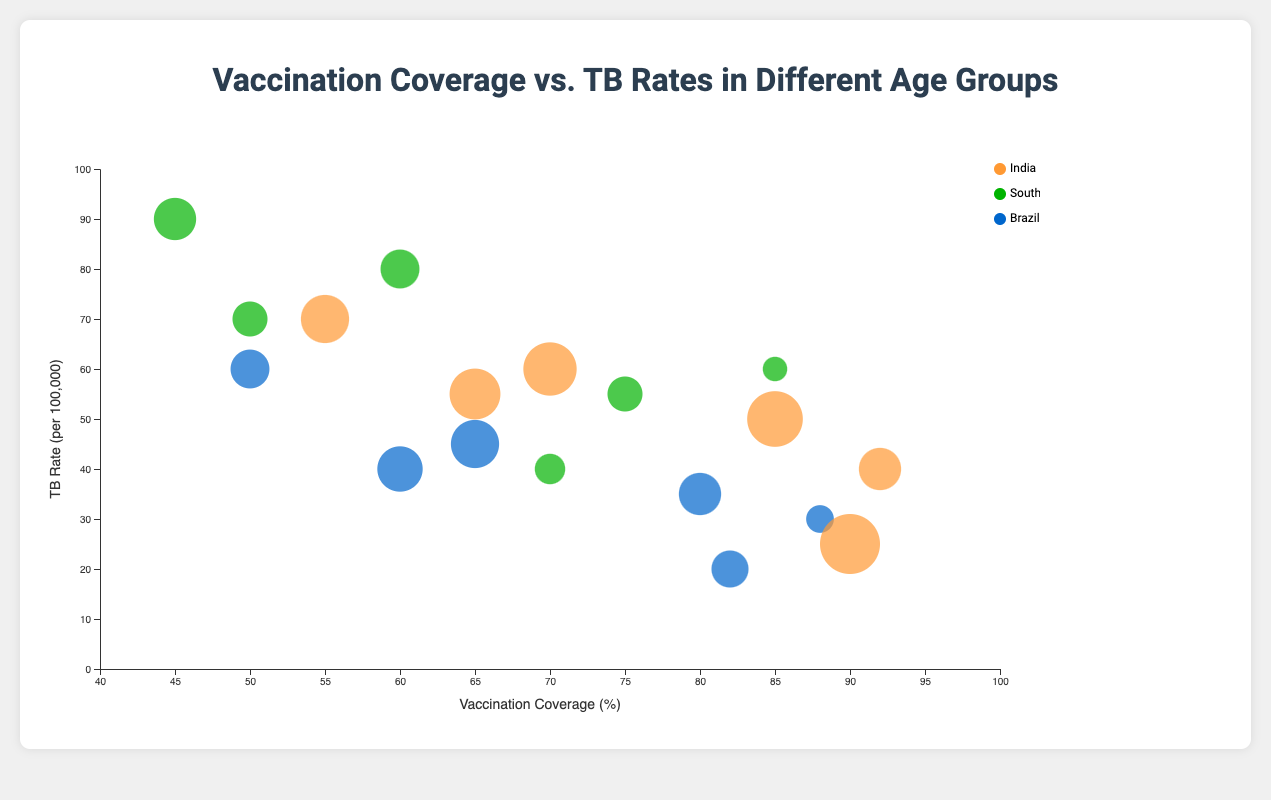What is the title of the figure? The title is located at the top center of the figure, typically in a larger font size, explaining what the chart is about.
Answer: Vaccination Coverage vs. TB Rates in Different Age Groups Which country has the highest TB rate in the age group 25-34? By looking at the TB rates on the vertical axis for the age group 25-34, identify the country represented by the highest bubble on the y-axis.
Answer: South Africa What is the vaccination coverage for Brazil in the age group of 35-44? Locate the bubble representing Brazil in the age group of 35-44 and reference the horizontal axis to find its vaccination coverage.
Answer: 60% How many countries are represented in the chart? By examining the legend or the colors in the chart, count the distinct categories which are labeled as different countries.
Answer: 3 For the age group 15-24, which country has the largest population? Find the bubbles for each country in the age group 15-24 and compare their sizes as size represents population.
Answer: India What is the difference in TB rates between the age groups 0-4 and 45+ for India? Locate bubbles for India in the age groups 0-4 and 45+. Subtract TB rate for age group 0-4 (40) from TB rate for age group 45+ (70).
Answer: 30 Which age group in Brazil has the lowest vaccination coverage? Find the circles representing Brazil in each age group and determine which one has the lowest value on the horizontal axis.
Answer: 45+ Compare the TB rates between South Africa and Brazil for the age group 0-4. Which is higher? Identify the TB rates for South Africa and Brazil in the 0-4 age group by looking at their positions on the y-axis and compare them.
Answer: South Africa How does the TB rate trend for India change across the age groups? Observe the bubbles representing India in each age group and note the vertical positions (TB rates) to describe the trend from 0-4 to 45+.
Answer: Increases with age What is the average vaccination coverage in the 5-14 age group across the three countries? Add the vaccination coverages for India (90%), South Africa (70%), and Brazil (82%), then divide by the number of countries, which is 3.
Answer: 80.67% 